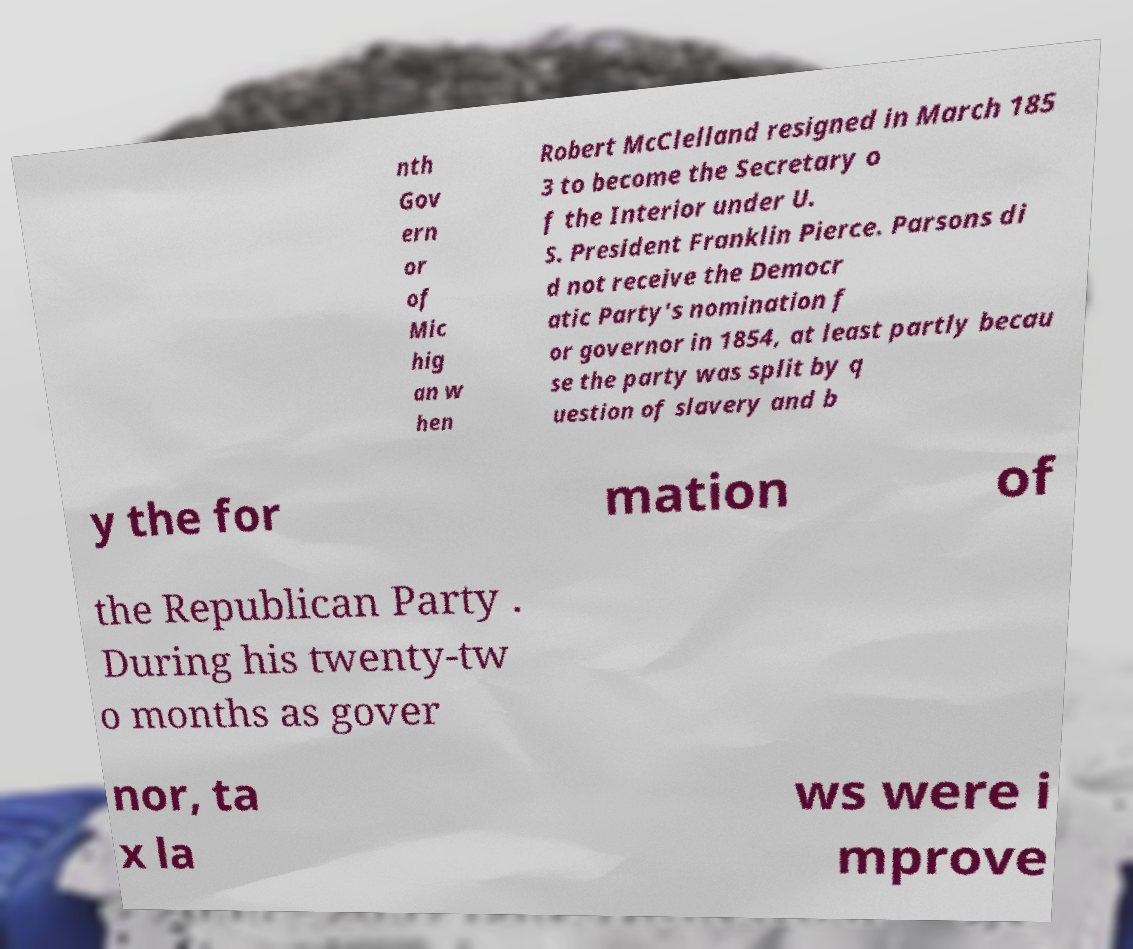There's text embedded in this image that I need extracted. Can you transcribe it verbatim? nth Gov ern or of Mic hig an w hen Robert McClelland resigned in March 185 3 to become the Secretary o f the Interior under U. S. President Franklin Pierce. Parsons di d not receive the Democr atic Party's nomination f or governor in 1854, at least partly becau se the party was split by q uestion of slavery and b y the for mation of the Republican Party . During his twenty-tw o months as gover nor, ta x la ws were i mprove 